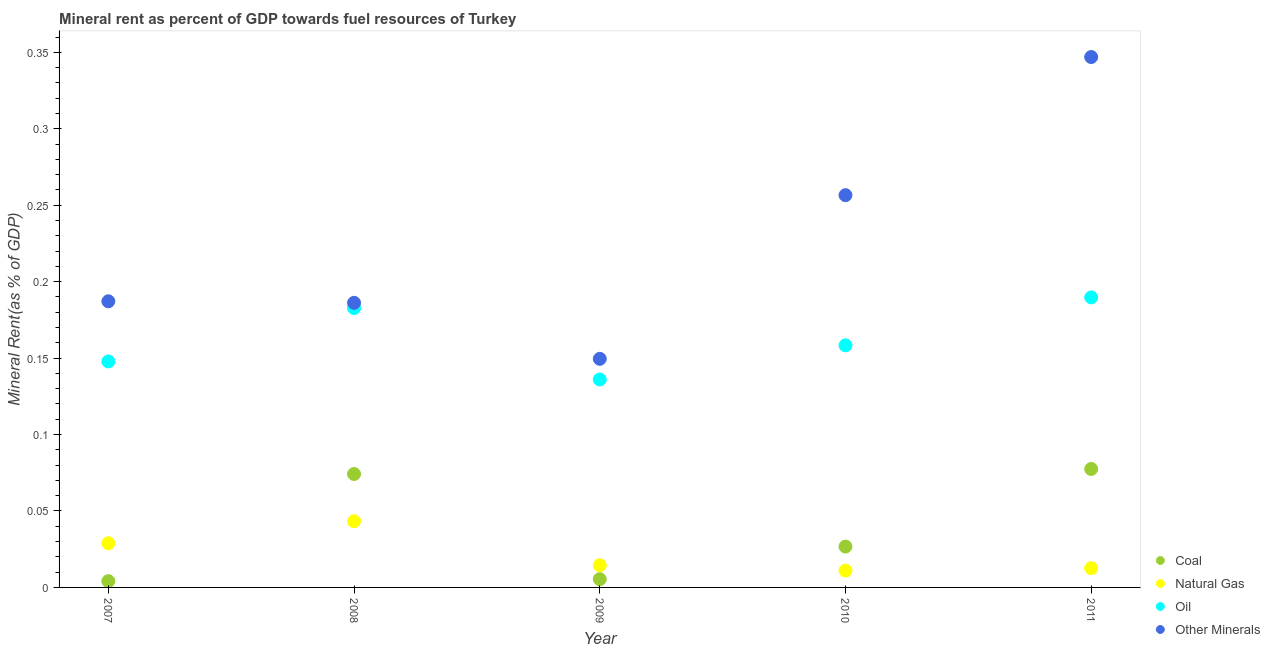How many different coloured dotlines are there?
Provide a short and direct response. 4. What is the oil rent in 2009?
Your answer should be compact. 0.14. Across all years, what is the maximum natural gas rent?
Give a very brief answer. 0.04. Across all years, what is the minimum coal rent?
Give a very brief answer. 0. What is the total oil rent in the graph?
Your response must be concise. 0.81. What is the difference between the  rent of other minerals in 2008 and that in 2011?
Make the answer very short. -0.16. What is the difference between the coal rent in 2011 and the  rent of other minerals in 2010?
Keep it short and to the point. -0.18. What is the average  rent of other minerals per year?
Make the answer very short. 0.23. In the year 2010, what is the difference between the natural gas rent and coal rent?
Offer a very short reply. -0.02. What is the ratio of the natural gas rent in 2010 to that in 2011?
Your response must be concise. 0.88. Is the natural gas rent in 2009 less than that in 2011?
Your response must be concise. No. What is the difference between the highest and the second highest coal rent?
Keep it short and to the point. 0. What is the difference between the highest and the lowest  rent of other minerals?
Give a very brief answer. 0.2. In how many years, is the oil rent greater than the average oil rent taken over all years?
Make the answer very short. 2. Is the sum of the  rent of other minerals in 2007 and 2009 greater than the maximum coal rent across all years?
Ensure brevity in your answer.  Yes. Is it the case that in every year, the sum of the coal rent and natural gas rent is greater than the oil rent?
Provide a succinct answer. No. Is the coal rent strictly greater than the oil rent over the years?
Offer a terse response. No. How many years are there in the graph?
Make the answer very short. 5. Are the values on the major ticks of Y-axis written in scientific E-notation?
Provide a short and direct response. No. Does the graph contain any zero values?
Offer a terse response. No. How many legend labels are there?
Keep it short and to the point. 4. What is the title of the graph?
Offer a very short reply. Mineral rent as percent of GDP towards fuel resources of Turkey. What is the label or title of the Y-axis?
Offer a terse response. Mineral Rent(as % of GDP). What is the Mineral Rent(as % of GDP) of Coal in 2007?
Your answer should be very brief. 0. What is the Mineral Rent(as % of GDP) of Natural Gas in 2007?
Give a very brief answer. 0.03. What is the Mineral Rent(as % of GDP) in Oil in 2007?
Your answer should be compact. 0.15. What is the Mineral Rent(as % of GDP) of Other Minerals in 2007?
Provide a short and direct response. 0.19. What is the Mineral Rent(as % of GDP) of Coal in 2008?
Make the answer very short. 0.07. What is the Mineral Rent(as % of GDP) in Natural Gas in 2008?
Your response must be concise. 0.04. What is the Mineral Rent(as % of GDP) of Oil in 2008?
Give a very brief answer. 0.18. What is the Mineral Rent(as % of GDP) of Other Minerals in 2008?
Offer a very short reply. 0.19. What is the Mineral Rent(as % of GDP) in Coal in 2009?
Provide a short and direct response. 0.01. What is the Mineral Rent(as % of GDP) in Natural Gas in 2009?
Your answer should be compact. 0.01. What is the Mineral Rent(as % of GDP) in Oil in 2009?
Offer a terse response. 0.14. What is the Mineral Rent(as % of GDP) of Other Minerals in 2009?
Offer a terse response. 0.15. What is the Mineral Rent(as % of GDP) of Coal in 2010?
Your answer should be compact. 0.03. What is the Mineral Rent(as % of GDP) in Natural Gas in 2010?
Your response must be concise. 0.01. What is the Mineral Rent(as % of GDP) of Oil in 2010?
Your answer should be compact. 0.16. What is the Mineral Rent(as % of GDP) of Other Minerals in 2010?
Provide a short and direct response. 0.26. What is the Mineral Rent(as % of GDP) of Coal in 2011?
Provide a succinct answer. 0.08. What is the Mineral Rent(as % of GDP) in Natural Gas in 2011?
Make the answer very short. 0.01. What is the Mineral Rent(as % of GDP) in Oil in 2011?
Provide a short and direct response. 0.19. What is the Mineral Rent(as % of GDP) in Other Minerals in 2011?
Keep it short and to the point. 0.35. Across all years, what is the maximum Mineral Rent(as % of GDP) of Coal?
Your answer should be compact. 0.08. Across all years, what is the maximum Mineral Rent(as % of GDP) in Natural Gas?
Give a very brief answer. 0.04. Across all years, what is the maximum Mineral Rent(as % of GDP) in Oil?
Give a very brief answer. 0.19. Across all years, what is the maximum Mineral Rent(as % of GDP) in Other Minerals?
Make the answer very short. 0.35. Across all years, what is the minimum Mineral Rent(as % of GDP) in Coal?
Give a very brief answer. 0. Across all years, what is the minimum Mineral Rent(as % of GDP) of Natural Gas?
Keep it short and to the point. 0.01. Across all years, what is the minimum Mineral Rent(as % of GDP) of Oil?
Give a very brief answer. 0.14. Across all years, what is the minimum Mineral Rent(as % of GDP) of Other Minerals?
Offer a terse response. 0.15. What is the total Mineral Rent(as % of GDP) in Coal in the graph?
Provide a short and direct response. 0.19. What is the total Mineral Rent(as % of GDP) in Natural Gas in the graph?
Your answer should be very brief. 0.11. What is the total Mineral Rent(as % of GDP) of Oil in the graph?
Your answer should be compact. 0.81. What is the total Mineral Rent(as % of GDP) of Other Minerals in the graph?
Your answer should be very brief. 1.13. What is the difference between the Mineral Rent(as % of GDP) in Coal in 2007 and that in 2008?
Keep it short and to the point. -0.07. What is the difference between the Mineral Rent(as % of GDP) in Natural Gas in 2007 and that in 2008?
Make the answer very short. -0.01. What is the difference between the Mineral Rent(as % of GDP) in Oil in 2007 and that in 2008?
Offer a very short reply. -0.03. What is the difference between the Mineral Rent(as % of GDP) in Other Minerals in 2007 and that in 2008?
Offer a very short reply. 0. What is the difference between the Mineral Rent(as % of GDP) in Coal in 2007 and that in 2009?
Keep it short and to the point. -0. What is the difference between the Mineral Rent(as % of GDP) of Natural Gas in 2007 and that in 2009?
Provide a short and direct response. 0.01. What is the difference between the Mineral Rent(as % of GDP) in Oil in 2007 and that in 2009?
Your response must be concise. 0.01. What is the difference between the Mineral Rent(as % of GDP) of Other Minerals in 2007 and that in 2009?
Provide a short and direct response. 0.04. What is the difference between the Mineral Rent(as % of GDP) in Coal in 2007 and that in 2010?
Provide a short and direct response. -0.02. What is the difference between the Mineral Rent(as % of GDP) in Natural Gas in 2007 and that in 2010?
Offer a very short reply. 0.02. What is the difference between the Mineral Rent(as % of GDP) in Oil in 2007 and that in 2010?
Ensure brevity in your answer.  -0.01. What is the difference between the Mineral Rent(as % of GDP) of Other Minerals in 2007 and that in 2010?
Your response must be concise. -0.07. What is the difference between the Mineral Rent(as % of GDP) of Coal in 2007 and that in 2011?
Offer a terse response. -0.07. What is the difference between the Mineral Rent(as % of GDP) in Natural Gas in 2007 and that in 2011?
Provide a short and direct response. 0.02. What is the difference between the Mineral Rent(as % of GDP) in Oil in 2007 and that in 2011?
Your answer should be very brief. -0.04. What is the difference between the Mineral Rent(as % of GDP) in Other Minerals in 2007 and that in 2011?
Provide a short and direct response. -0.16. What is the difference between the Mineral Rent(as % of GDP) of Coal in 2008 and that in 2009?
Your response must be concise. 0.07. What is the difference between the Mineral Rent(as % of GDP) of Natural Gas in 2008 and that in 2009?
Your response must be concise. 0.03. What is the difference between the Mineral Rent(as % of GDP) in Oil in 2008 and that in 2009?
Provide a succinct answer. 0.05. What is the difference between the Mineral Rent(as % of GDP) in Other Minerals in 2008 and that in 2009?
Offer a very short reply. 0.04. What is the difference between the Mineral Rent(as % of GDP) of Coal in 2008 and that in 2010?
Your response must be concise. 0.05. What is the difference between the Mineral Rent(as % of GDP) of Natural Gas in 2008 and that in 2010?
Your response must be concise. 0.03. What is the difference between the Mineral Rent(as % of GDP) of Oil in 2008 and that in 2010?
Provide a succinct answer. 0.02. What is the difference between the Mineral Rent(as % of GDP) in Other Minerals in 2008 and that in 2010?
Your response must be concise. -0.07. What is the difference between the Mineral Rent(as % of GDP) in Coal in 2008 and that in 2011?
Make the answer very short. -0. What is the difference between the Mineral Rent(as % of GDP) in Natural Gas in 2008 and that in 2011?
Offer a terse response. 0.03. What is the difference between the Mineral Rent(as % of GDP) of Oil in 2008 and that in 2011?
Make the answer very short. -0.01. What is the difference between the Mineral Rent(as % of GDP) of Other Minerals in 2008 and that in 2011?
Provide a short and direct response. -0.16. What is the difference between the Mineral Rent(as % of GDP) of Coal in 2009 and that in 2010?
Offer a terse response. -0.02. What is the difference between the Mineral Rent(as % of GDP) in Natural Gas in 2009 and that in 2010?
Your response must be concise. 0. What is the difference between the Mineral Rent(as % of GDP) in Oil in 2009 and that in 2010?
Offer a terse response. -0.02. What is the difference between the Mineral Rent(as % of GDP) in Other Minerals in 2009 and that in 2010?
Keep it short and to the point. -0.11. What is the difference between the Mineral Rent(as % of GDP) of Coal in 2009 and that in 2011?
Ensure brevity in your answer.  -0.07. What is the difference between the Mineral Rent(as % of GDP) in Natural Gas in 2009 and that in 2011?
Keep it short and to the point. 0. What is the difference between the Mineral Rent(as % of GDP) in Oil in 2009 and that in 2011?
Offer a terse response. -0.05. What is the difference between the Mineral Rent(as % of GDP) in Other Minerals in 2009 and that in 2011?
Your answer should be very brief. -0.2. What is the difference between the Mineral Rent(as % of GDP) of Coal in 2010 and that in 2011?
Your answer should be very brief. -0.05. What is the difference between the Mineral Rent(as % of GDP) of Natural Gas in 2010 and that in 2011?
Provide a short and direct response. -0. What is the difference between the Mineral Rent(as % of GDP) of Oil in 2010 and that in 2011?
Provide a short and direct response. -0.03. What is the difference between the Mineral Rent(as % of GDP) in Other Minerals in 2010 and that in 2011?
Provide a short and direct response. -0.09. What is the difference between the Mineral Rent(as % of GDP) of Coal in 2007 and the Mineral Rent(as % of GDP) of Natural Gas in 2008?
Provide a short and direct response. -0.04. What is the difference between the Mineral Rent(as % of GDP) in Coal in 2007 and the Mineral Rent(as % of GDP) in Oil in 2008?
Your answer should be compact. -0.18. What is the difference between the Mineral Rent(as % of GDP) of Coal in 2007 and the Mineral Rent(as % of GDP) of Other Minerals in 2008?
Your answer should be compact. -0.18. What is the difference between the Mineral Rent(as % of GDP) in Natural Gas in 2007 and the Mineral Rent(as % of GDP) in Oil in 2008?
Provide a succinct answer. -0.15. What is the difference between the Mineral Rent(as % of GDP) in Natural Gas in 2007 and the Mineral Rent(as % of GDP) in Other Minerals in 2008?
Your response must be concise. -0.16. What is the difference between the Mineral Rent(as % of GDP) of Oil in 2007 and the Mineral Rent(as % of GDP) of Other Minerals in 2008?
Provide a short and direct response. -0.04. What is the difference between the Mineral Rent(as % of GDP) in Coal in 2007 and the Mineral Rent(as % of GDP) in Natural Gas in 2009?
Provide a succinct answer. -0.01. What is the difference between the Mineral Rent(as % of GDP) in Coal in 2007 and the Mineral Rent(as % of GDP) in Oil in 2009?
Provide a short and direct response. -0.13. What is the difference between the Mineral Rent(as % of GDP) of Coal in 2007 and the Mineral Rent(as % of GDP) of Other Minerals in 2009?
Offer a terse response. -0.15. What is the difference between the Mineral Rent(as % of GDP) of Natural Gas in 2007 and the Mineral Rent(as % of GDP) of Oil in 2009?
Your answer should be very brief. -0.11. What is the difference between the Mineral Rent(as % of GDP) of Natural Gas in 2007 and the Mineral Rent(as % of GDP) of Other Minerals in 2009?
Make the answer very short. -0.12. What is the difference between the Mineral Rent(as % of GDP) in Oil in 2007 and the Mineral Rent(as % of GDP) in Other Minerals in 2009?
Offer a terse response. -0. What is the difference between the Mineral Rent(as % of GDP) of Coal in 2007 and the Mineral Rent(as % of GDP) of Natural Gas in 2010?
Offer a terse response. -0.01. What is the difference between the Mineral Rent(as % of GDP) of Coal in 2007 and the Mineral Rent(as % of GDP) of Oil in 2010?
Provide a short and direct response. -0.15. What is the difference between the Mineral Rent(as % of GDP) of Coal in 2007 and the Mineral Rent(as % of GDP) of Other Minerals in 2010?
Ensure brevity in your answer.  -0.25. What is the difference between the Mineral Rent(as % of GDP) in Natural Gas in 2007 and the Mineral Rent(as % of GDP) in Oil in 2010?
Ensure brevity in your answer.  -0.13. What is the difference between the Mineral Rent(as % of GDP) of Natural Gas in 2007 and the Mineral Rent(as % of GDP) of Other Minerals in 2010?
Keep it short and to the point. -0.23. What is the difference between the Mineral Rent(as % of GDP) of Oil in 2007 and the Mineral Rent(as % of GDP) of Other Minerals in 2010?
Give a very brief answer. -0.11. What is the difference between the Mineral Rent(as % of GDP) of Coal in 2007 and the Mineral Rent(as % of GDP) of Natural Gas in 2011?
Provide a short and direct response. -0.01. What is the difference between the Mineral Rent(as % of GDP) of Coal in 2007 and the Mineral Rent(as % of GDP) of Oil in 2011?
Provide a short and direct response. -0.19. What is the difference between the Mineral Rent(as % of GDP) of Coal in 2007 and the Mineral Rent(as % of GDP) of Other Minerals in 2011?
Give a very brief answer. -0.34. What is the difference between the Mineral Rent(as % of GDP) of Natural Gas in 2007 and the Mineral Rent(as % of GDP) of Oil in 2011?
Offer a terse response. -0.16. What is the difference between the Mineral Rent(as % of GDP) of Natural Gas in 2007 and the Mineral Rent(as % of GDP) of Other Minerals in 2011?
Keep it short and to the point. -0.32. What is the difference between the Mineral Rent(as % of GDP) of Oil in 2007 and the Mineral Rent(as % of GDP) of Other Minerals in 2011?
Provide a short and direct response. -0.2. What is the difference between the Mineral Rent(as % of GDP) of Coal in 2008 and the Mineral Rent(as % of GDP) of Natural Gas in 2009?
Ensure brevity in your answer.  0.06. What is the difference between the Mineral Rent(as % of GDP) in Coal in 2008 and the Mineral Rent(as % of GDP) in Oil in 2009?
Provide a short and direct response. -0.06. What is the difference between the Mineral Rent(as % of GDP) of Coal in 2008 and the Mineral Rent(as % of GDP) of Other Minerals in 2009?
Keep it short and to the point. -0.08. What is the difference between the Mineral Rent(as % of GDP) of Natural Gas in 2008 and the Mineral Rent(as % of GDP) of Oil in 2009?
Make the answer very short. -0.09. What is the difference between the Mineral Rent(as % of GDP) of Natural Gas in 2008 and the Mineral Rent(as % of GDP) of Other Minerals in 2009?
Offer a very short reply. -0.11. What is the difference between the Mineral Rent(as % of GDP) in Oil in 2008 and the Mineral Rent(as % of GDP) in Other Minerals in 2009?
Your answer should be compact. 0.03. What is the difference between the Mineral Rent(as % of GDP) in Coal in 2008 and the Mineral Rent(as % of GDP) in Natural Gas in 2010?
Your answer should be very brief. 0.06. What is the difference between the Mineral Rent(as % of GDP) in Coal in 2008 and the Mineral Rent(as % of GDP) in Oil in 2010?
Keep it short and to the point. -0.08. What is the difference between the Mineral Rent(as % of GDP) of Coal in 2008 and the Mineral Rent(as % of GDP) of Other Minerals in 2010?
Your answer should be very brief. -0.18. What is the difference between the Mineral Rent(as % of GDP) of Natural Gas in 2008 and the Mineral Rent(as % of GDP) of Oil in 2010?
Provide a succinct answer. -0.12. What is the difference between the Mineral Rent(as % of GDP) of Natural Gas in 2008 and the Mineral Rent(as % of GDP) of Other Minerals in 2010?
Provide a short and direct response. -0.21. What is the difference between the Mineral Rent(as % of GDP) in Oil in 2008 and the Mineral Rent(as % of GDP) in Other Minerals in 2010?
Your answer should be very brief. -0.07. What is the difference between the Mineral Rent(as % of GDP) in Coal in 2008 and the Mineral Rent(as % of GDP) in Natural Gas in 2011?
Your response must be concise. 0.06. What is the difference between the Mineral Rent(as % of GDP) of Coal in 2008 and the Mineral Rent(as % of GDP) of Oil in 2011?
Your response must be concise. -0.12. What is the difference between the Mineral Rent(as % of GDP) in Coal in 2008 and the Mineral Rent(as % of GDP) in Other Minerals in 2011?
Offer a terse response. -0.27. What is the difference between the Mineral Rent(as % of GDP) of Natural Gas in 2008 and the Mineral Rent(as % of GDP) of Oil in 2011?
Ensure brevity in your answer.  -0.15. What is the difference between the Mineral Rent(as % of GDP) in Natural Gas in 2008 and the Mineral Rent(as % of GDP) in Other Minerals in 2011?
Ensure brevity in your answer.  -0.3. What is the difference between the Mineral Rent(as % of GDP) of Oil in 2008 and the Mineral Rent(as % of GDP) of Other Minerals in 2011?
Offer a very short reply. -0.16. What is the difference between the Mineral Rent(as % of GDP) in Coal in 2009 and the Mineral Rent(as % of GDP) in Natural Gas in 2010?
Provide a short and direct response. -0.01. What is the difference between the Mineral Rent(as % of GDP) of Coal in 2009 and the Mineral Rent(as % of GDP) of Oil in 2010?
Make the answer very short. -0.15. What is the difference between the Mineral Rent(as % of GDP) of Coal in 2009 and the Mineral Rent(as % of GDP) of Other Minerals in 2010?
Give a very brief answer. -0.25. What is the difference between the Mineral Rent(as % of GDP) of Natural Gas in 2009 and the Mineral Rent(as % of GDP) of Oil in 2010?
Your response must be concise. -0.14. What is the difference between the Mineral Rent(as % of GDP) of Natural Gas in 2009 and the Mineral Rent(as % of GDP) of Other Minerals in 2010?
Your answer should be compact. -0.24. What is the difference between the Mineral Rent(as % of GDP) of Oil in 2009 and the Mineral Rent(as % of GDP) of Other Minerals in 2010?
Your answer should be compact. -0.12. What is the difference between the Mineral Rent(as % of GDP) in Coal in 2009 and the Mineral Rent(as % of GDP) in Natural Gas in 2011?
Ensure brevity in your answer.  -0.01. What is the difference between the Mineral Rent(as % of GDP) in Coal in 2009 and the Mineral Rent(as % of GDP) in Oil in 2011?
Your response must be concise. -0.18. What is the difference between the Mineral Rent(as % of GDP) of Coal in 2009 and the Mineral Rent(as % of GDP) of Other Minerals in 2011?
Offer a very short reply. -0.34. What is the difference between the Mineral Rent(as % of GDP) in Natural Gas in 2009 and the Mineral Rent(as % of GDP) in Oil in 2011?
Offer a terse response. -0.18. What is the difference between the Mineral Rent(as % of GDP) of Natural Gas in 2009 and the Mineral Rent(as % of GDP) of Other Minerals in 2011?
Make the answer very short. -0.33. What is the difference between the Mineral Rent(as % of GDP) of Oil in 2009 and the Mineral Rent(as % of GDP) of Other Minerals in 2011?
Offer a very short reply. -0.21. What is the difference between the Mineral Rent(as % of GDP) of Coal in 2010 and the Mineral Rent(as % of GDP) of Natural Gas in 2011?
Your answer should be compact. 0.01. What is the difference between the Mineral Rent(as % of GDP) of Coal in 2010 and the Mineral Rent(as % of GDP) of Oil in 2011?
Offer a very short reply. -0.16. What is the difference between the Mineral Rent(as % of GDP) in Coal in 2010 and the Mineral Rent(as % of GDP) in Other Minerals in 2011?
Your response must be concise. -0.32. What is the difference between the Mineral Rent(as % of GDP) of Natural Gas in 2010 and the Mineral Rent(as % of GDP) of Oil in 2011?
Give a very brief answer. -0.18. What is the difference between the Mineral Rent(as % of GDP) of Natural Gas in 2010 and the Mineral Rent(as % of GDP) of Other Minerals in 2011?
Provide a short and direct response. -0.34. What is the difference between the Mineral Rent(as % of GDP) in Oil in 2010 and the Mineral Rent(as % of GDP) in Other Minerals in 2011?
Your answer should be very brief. -0.19. What is the average Mineral Rent(as % of GDP) of Coal per year?
Offer a terse response. 0.04. What is the average Mineral Rent(as % of GDP) of Natural Gas per year?
Offer a terse response. 0.02. What is the average Mineral Rent(as % of GDP) of Oil per year?
Provide a succinct answer. 0.16. What is the average Mineral Rent(as % of GDP) in Other Minerals per year?
Ensure brevity in your answer.  0.23. In the year 2007, what is the difference between the Mineral Rent(as % of GDP) of Coal and Mineral Rent(as % of GDP) of Natural Gas?
Ensure brevity in your answer.  -0.02. In the year 2007, what is the difference between the Mineral Rent(as % of GDP) of Coal and Mineral Rent(as % of GDP) of Oil?
Your response must be concise. -0.14. In the year 2007, what is the difference between the Mineral Rent(as % of GDP) of Coal and Mineral Rent(as % of GDP) of Other Minerals?
Give a very brief answer. -0.18. In the year 2007, what is the difference between the Mineral Rent(as % of GDP) in Natural Gas and Mineral Rent(as % of GDP) in Oil?
Your answer should be very brief. -0.12. In the year 2007, what is the difference between the Mineral Rent(as % of GDP) of Natural Gas and Mineral Rent(as % of GDP) of Other Minerals?
Offer a terse response. -0.16. In the year 2007, what is the difference between the Mineral Rent(as % of GDP) of Oil and Mineral Rent(as % of GDP) of Other Minerals?
Your answer should be very brief. -0.04. In the year 2008, what is the difference between the Mineral Rent(as % of GDP) of Coal and Mineral Rent(as % of GDP) of Natural Gas?
Your answer should be compact. 0.03. In the year 2008, what is the difference between the Mineral Rent(as % of GDP) in Coal and Mineral Rent(as % of GDP) in Oil?
Offer a very short reply. -0.11. In the year 2008, what is the difference between the Mineral Rent(as % of GDP) in Coal and Mineral Rent(as % of GDP) in Other Minerals?
Offer a terse response. -0.11. In the year 2008, what is the difference between the Mineral Rent(as % of GDP) in Natural Gas and Mineral Rent(as % of GDP) in Oil?
Your answer should be compact. -0.14. In the year 2008, what is the difference between the Mineral Rent(as % of GDP) in Natural Gas and Mineral Rent(as % of GDP) in Other Minerals?
Make the answer very short. -0.14. In the year 2008, what is the difference between the Mineral Rent(as % of GDP) in Oil and Mineral Rent(as % of GDP) in Other Minerals?
Your answer should be compact. -0. In the year 2009, what is the difference between the Mineral Rent(as % of GDP) in Coal and Mineral Rent(as % of GDP) in Natural Gas?
Ensure brevity in your answer.  -0.01. In the year 2009, what is the difference between the Mineral Rent(as % of GDP) of Coal and Mineral Rent(as % of GDP) of Oil?
Your answer should be very brief. -0.13. In the year 2009, what is the difference between the Mineral Rent(as % of GDP) of Coal and Mineral Rent(as % of GDP) of Other Minerals?
Your answer should be compact. -0.14. In the year 2009, what is the difference between the Mineral Rent(as % of GDP) of Natural Gas and Mineral Rent(as % of GDP) of Oil?
Your answer should be compact. -0.12. In the year 2009, what is the difference between the Mineral Rent(as % of GDP) in Natural Gas and Mineral Rent(as % of GDP) in Other Minerals?
Your answer should be compact. -0.14. In the year 2009, what is the difference between the Mineral Rent(as % of GDP) in Oil and Mineral Rent(as % of GDP) in Other Minerals?
Your response must be concise. -0.01. In the year 2010, what is the difference between the Mineral Rent(as % of GDP) in Coal and Mineral Rent(as % of GDP) in Natural Gas?
Give a very brief answer. 0.02. In the year 2010, what is the difference between the Mineral Rent(as % of GDP) of Coal and Mineral Rent(as % of GDP) of Oil?
Ensure brevity in your answer.  -0.13. In the year 2010, what is the difference between the Mineral Rent(as % of GDP) of Coal and Mineral Rent(as % of GDP) of Other Minerals?
Make the answer very short. -0.23. In the year 2010, what is the difference between the Mineral Rent(as % of GDP) in Natural Gas and Mineral Rent(as % of GDP) in Oil?
Ensure brevity in your answer.  -0.15. In the year 2010, what is the difference between the Mineral Rent(as % of GDP) of Natural Gas and Mineral Rent(as % of GDP) of Other Minerals?
Your answer should be very brief. -0.25. In the year 2010, what is the difference between the Mineral Rent(as % of GDP) in Oil and Mineral Rent(as % of GDP) in Other Minerals?
Offer a very short reply. -0.1. In the year 2011, what is the difference between the Mineral Rent(as % of GDP) of Coal and Mineral Rent(as % of GDP) of Natural Gas?
Offer a terse response. 0.06. In the year 2011, what is the difference between the Mineral Rent(as % of GDP) in Coal and Mineral Rent(as % of GDP) in Oil?
Give a very brief answer. -0.11. In the year 2011, what is the difference between the Mineral Rent(as % of GDP) in Coal and Mineral Rent(as % of GDP) in Other Minerals?
Provide a short and direct response. -0.27. In the year 2011, what is the difference between the Mineral Rent(as % of GDP) of Natural Gas and Mineral Rent(as % of GDP) of Oil?
Your response must be concise. -0.18. In the year 2011, what is the difference between the Mineral Rent(as % of GDP) in Natural Gas and Mineral Rent(as % of GDP) in Other Minerals?
Provide a short and direct response. -0.33. In the year 2011, what is the difference between the Mineral Rent(as % of GDP) of Oil and Mineral Rent(as % of GDP) of Other Minerals?
Your response must be concise. -0.16. What is the ratio of the Mineral Rent(as % of GDP) of Coal in 2007 to that in 2008?
Ensure brevity in your answer.  0.06. What is the ratio of the Mineral Rent(as % of GDP) of Natural Gas in 2007 to that in 2008?
Offer a very short reply. 0.67. What is the ratio of the Mineral Rent(as % of GDP) in Oil in 2007 to that in 2008?
Provide a short and direct response. 0.81. What is the ratio of the Mineral Rent(as % of GDP) in Other Minerals in 2007 to that in 2008?
Make the answer very short. 1.01. What is the ratio of the Mineral Rent(as % of GDP) in Coal in 2007 to that in 2009?
Your response must be concise. 0.76. What is the ratio of the Mineral Rent(as % of GDP) of Natural Gas in 2007 to that in 2009?
Offer a terse response. 2. What is the ratio of the Mineral Rent(as % of GDP) of Oil in 2007 to that in 2009?
Provide a short and direct response. 1.09. What is the ratio of the Mineral Rent(as % of GDP) in Other Minerals in 2007 to that in 2009?
Ensure brevity in your answer.  1.25. What is the ratio of the Mineral Rent(as % of GDP) in Coal in 2007 to that in 2010?
Make the answer very short. 0.15. What is the ratio of the Mineral Rent(as % of GDP) in Natural Gas in 2007 to that in 2010?
Provide a succinct answer. 2.62. What is the ratio of the Mineral Rent(as % of GDP) in Oil in 2007 to that in 2010?
Your response must be concise. 0.93. What is the ratio of the Mineral Rent(as % of GDP) in Other Minerals in 2007 to that in 2010?
Ensure brevity in your answer.  0.73. What is the ratio of the Mineral Rent(as % of GDP) in Coal in 2007 to that in 2011?
Make the answer very short. 0.05. What is the ratio of the Mineral Rent(as % of GDP) of Natural Gas in 2007 to that in 2011?
Give a very brief answer. 2.3. What is the ratio of the Mineral Rent(as % of GDP) of Oil in 2007 to that in 2011?
Your response must be concise. 0.78. What is the ratio of the Mineral Rent(as % of GDP) in Other Minerals in 2007 to that in 2011?
Provide a succinct answer. 0.54. What is the ratio of the Mineral Rent(as % of GDP) of Coal in 2008 to that in 2009?
Offer a very short reply. 13.69. What is the ratio of the Mineral Rent(as % of GDP) in Natural Gas in 2008 to that in 2009?
Offer a very short reply. 2.99. What is the ratio of the Mineral Rent(as % of GDP) of Oil in 2008 to that in 2009?
Provide a succinct answer. 1.34. What is the ratio of the Mineral Rent(as % of GDP) of Other Minerals in 2008 to that in 2009?
Your answer should be very brief. 1.25. What is the ratio of the Mineral Rent(as % of GDP) of Coal in 2008 to that in 2010?
Make the answer very short. 2.78. What is the ratio of the Mineral Rent(as % of GDP) of Natural Gas in 2008 to that in 2010?
Give a very brief answer. 3.93. What is the ratio of the Mineral Rent(as % of GDP) in Oil in 2008 to that in 2010?
Your answer should be very brief. 1.15. What is the ratio of the Mineral Rent(as % of GDP) in Other Minerals in 2008 to that in 2010?
Give a very brief answer. 0.73. What is the ratio of the Mineral Rent(as % of GDP) of Coal in 2008 to that in 2011?
Ensure brevity in your answer.  0.96. What is the ratio of the Mineral Rent(as % of GDP) in Natural Gas in 2008 to that in 2011?
Offer a very short reply. 3.44. What is the ratio of the Mineral Rent(as % of GDP) of Oil in 2008 to that in 2011?
Keep it short and to the point. 0.96. What is the ratio of the Mineral Rent(as % of GDP) in Other Minerals in 2008 to that in 2011?
Provide a short and direct response. 0.54. What is the ratio of the Mineral Rent(as % of GDP) of Coal in 2009 to that in 2010?
Offer a terse response. 0.2. What is the ratio of the Mineral Rent(as % of GDP) of Natural Gas in 2009 to that in 2010?
Provide a short and direct response. 1.31. What is the ratio of the Mineral Rent(as % of GDP) in Oil in 2009 to that in 2010?
Offer a very short reply. 0.86. What is the ratio of the Mineral Rent(as % of GDP) in Other Minerals in 2009 to that in 2010?
Your answer should be very brief. 0.58. What is the ratio of the Mineral Rent(as % of GDP) of Coal in 2009 to that in 2011?
Make the answer very short. 0.07. What is the ratio of the Mineral Rent(as % of GDP) of Natural Gas in 2009 to that in 2011?
Offer a very short reply. 1.15. What is the ratio of the Mineral Rent(as % of GDP) in Oil in 2009 to that in 2011?
Give a very brief answer. 0.72. What is the ratio of the Mineral Rent(as % of GDP) of Other Minerals in 2009 to that in 2011?
Provide a succinct answer. 0.43. What is the ratio of the Mineral Rent(as % of GDP) in Coal in 2010 to that in 2011?
Provide a short and direct response. 0.34. What is the ratio of the Mineral Rent(as % of GDP) of Natural Gas in 2010 to that in 2011?
Make the answer very short. 0.88. What is the ratio of the Mineral Rent(as % of GDP) of Oil in 2010 to that in 2011?
Your response must be concise. 0.83. What is the ratio of the Mineral Rent(as % of GDP) in Other Minerals in 2010 to that in 2011?
Make the answer very short. 0.74. What is the difference between the highest and the second highest Mineral Rent(as % of GDP) of Coal?
Provide a short and direct response. 0. What is the difference between the highest and the second highest Mineral Rent(as % of GDP) of Natural Gas?
Your response must be concise. 0.01. What is the difference between the highest and the second highest Mineral Rent(as % of GDP) of Oil?
Your answer should be very brief. 0.01. What is the difference between the highest and the second highest Mineral Rent(as % of GDP) in Other Minerals?
Ensure brevity in your answer.  0.09. What is the difference between the highest and the lowest Mineral Rent(as % of GDP) of Coal?
Provide a short and direct response. 0.07. What is the difference between the highest and the lowest Mineral Rent(as % of GDP) of Natural Gas?
Keep it short and to the point. 0.03. What is the difference between the highest and the lowest Mineral Rent(as % of GDP) of Oil?
Your answer should be very brief. 0.05. What is the difference between the highest and the lowest Mineral Rent(as % of GDP) of Other Minerals?
Provide a succinct answer. 0.2. 